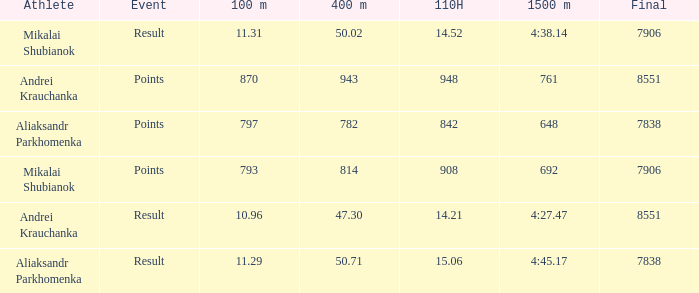What was the 400m that had a 110H greater than 14.21, a final of more than 7838, and having result in events? 1.0. 